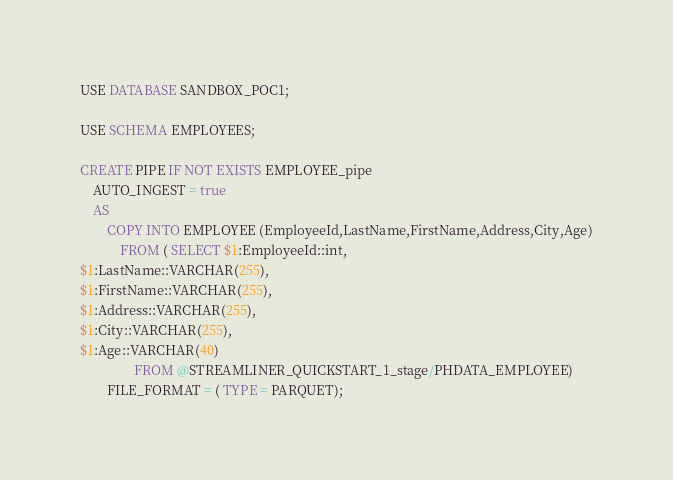<code> <loc_0><loc_0><loc_500><loc_500><_SQL_>USE DATABASE SANDBOX_POC1;

USE SCHEMA EMPLOYEES;

CREATE PIPE IF NOT EXISTS EMPLOYEE_pipe
	AUTO_INGEST = true
	AS
		COPY INTO EMPLOYEE (EmployeeId,LastName,FirstName,Address,City,Age)
			FROM ( SELECT $1:EmployeeId::int,
$1:LastName::VARCHAR(255),
$1:FirstName::VARCHAR(255),
$1:Address::VARCHAR(255),
$1:City::VARCHAR(255),
$1:Age::VARCHAR(40)
				FROM @STREAMLINER_QUICKSTART_1_stage/PHDATA_EMPLOYEE)
		FILE_FORMAT = ( TYPE = PARQUET);</code> 